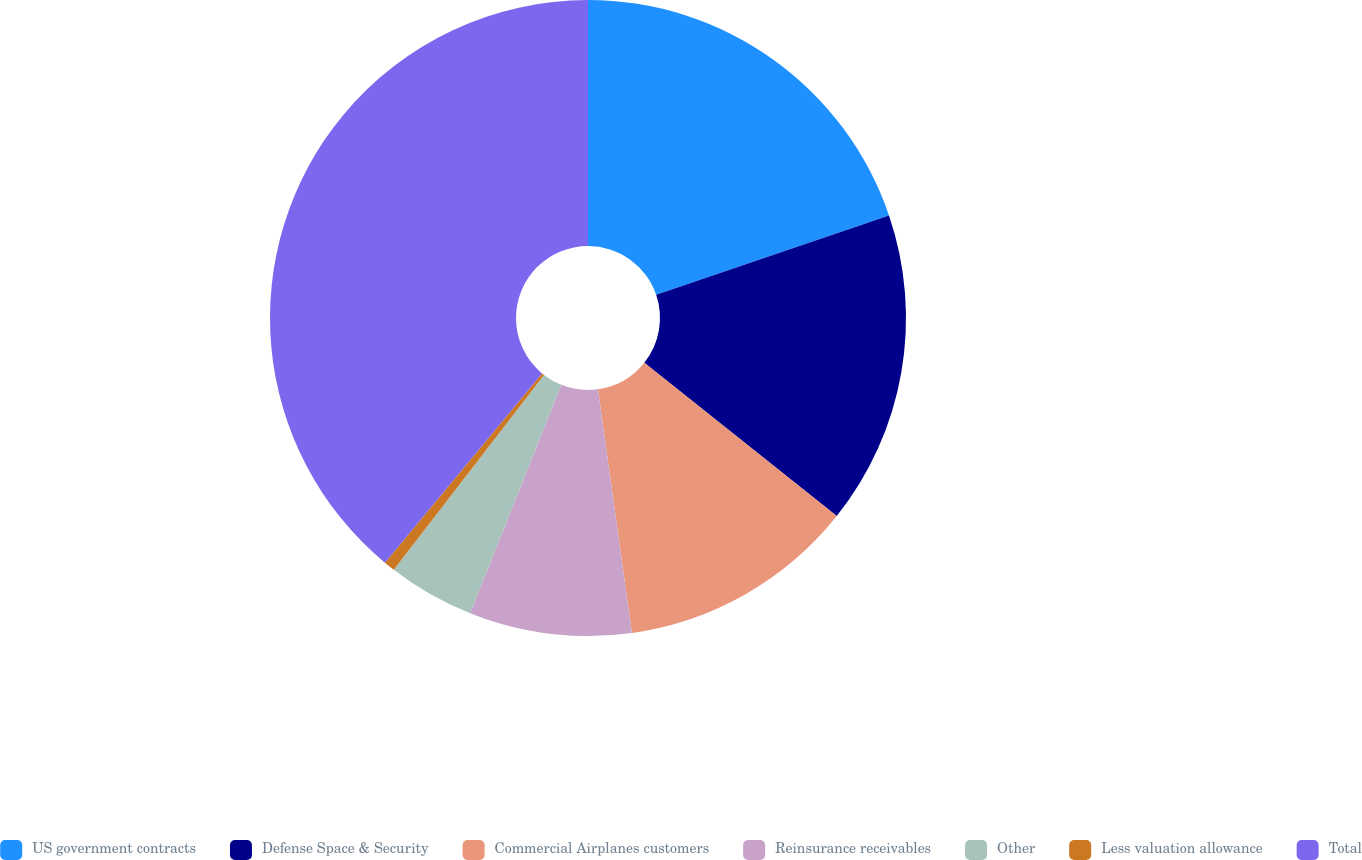<chart> <loc_0><loc_0><loc_500><loc_500><pie_chart><fcel>US government contracts<fcel>Defense Space & Security<fcel>Commercial Airplanes customers<fcel>Reinsurance receivables<fcel>Other<fcel>Less valuation allowance<fcel>Total<nl><fcel>19.77%<fcel>15.93%<fcel>12.09%<fcel>8.25%<fcel>4.41%<fcel>0.57%<fcel>38.97%<nl></chart> 